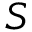<formula> <loc_0><loc_0><loc_500><loc_500>S</formula> 